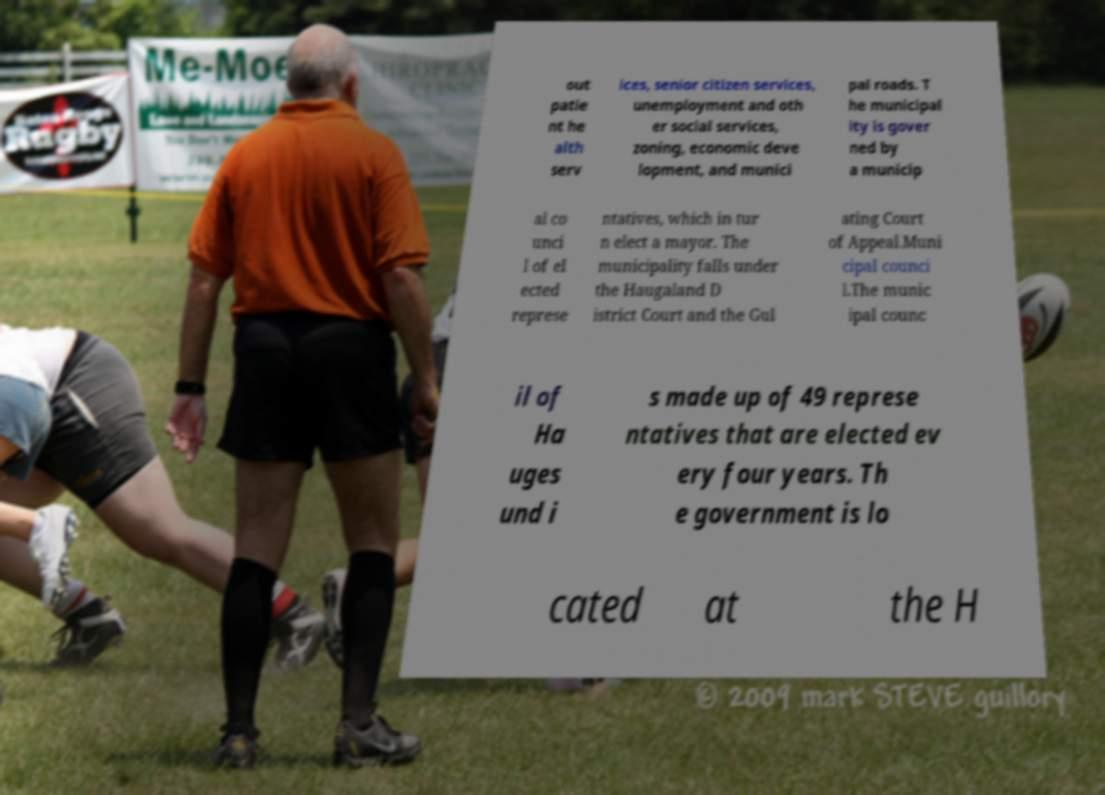Please identify and transcribe the text found in this image. out patie nt he alth serv ices, senior citizen services, unemployment and oth er social services, zoning, economic deve lopment, and munici pal roads. T he municipal ity is gover ned by a municip al co unci l of el ected represe ntatives, which in tur n elect a mayor. The municipality falls under the Haugaland D istrict Court and the Gul ating Court of Appeal.Muni cipal counci l.The munic ipal counc il of Ha uges und i s made up of 49 represe ntatives that are elected ev ery four years. Th e government is lo cated at the H 